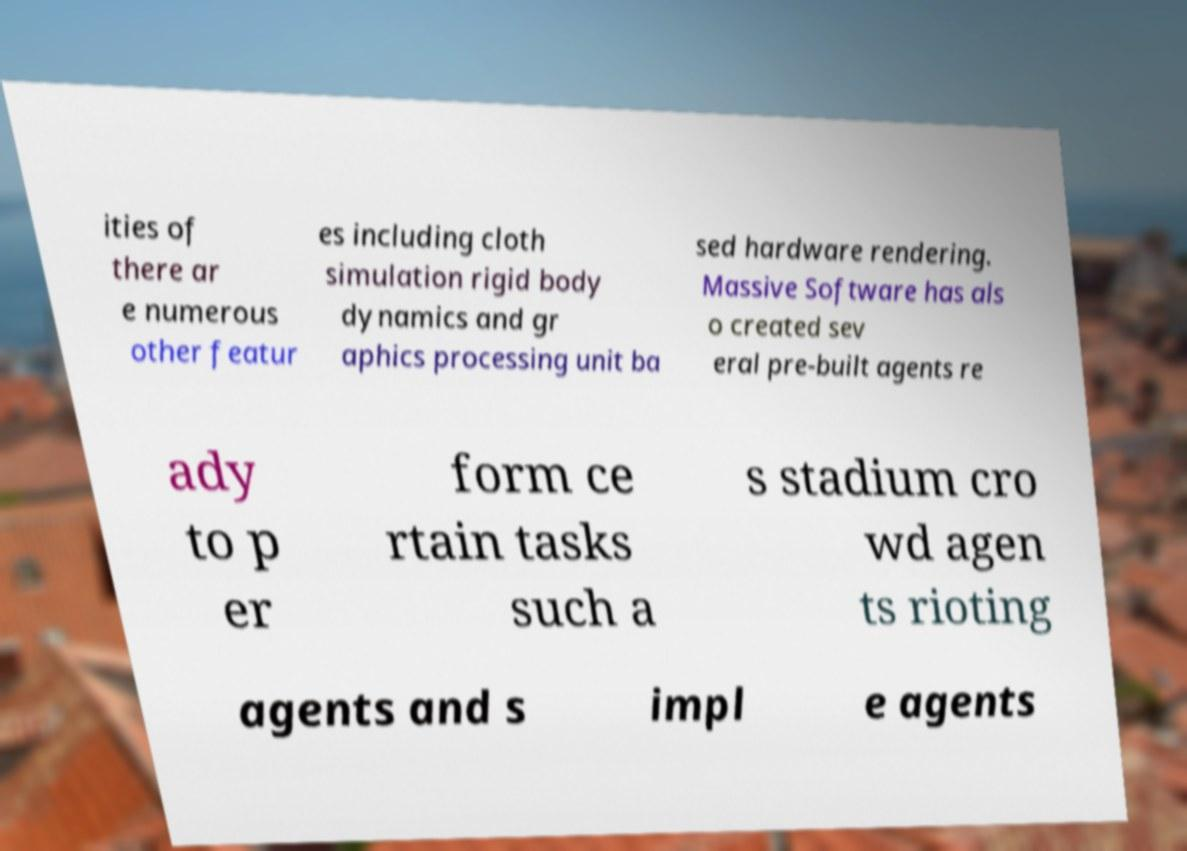For documentation purposes, I need the text within this image transcribed. Could you provide that? ities of there ar e numerous other featur es including cloth simulation rigid body dynamics and gr aphics processing unit ba sed hardware rendering. Massive Software has als o created sev eral pre-built agents re ady to p er form ce rtain tasks such a s stadium cro wd agen ts rioting agents and s impl e agents 